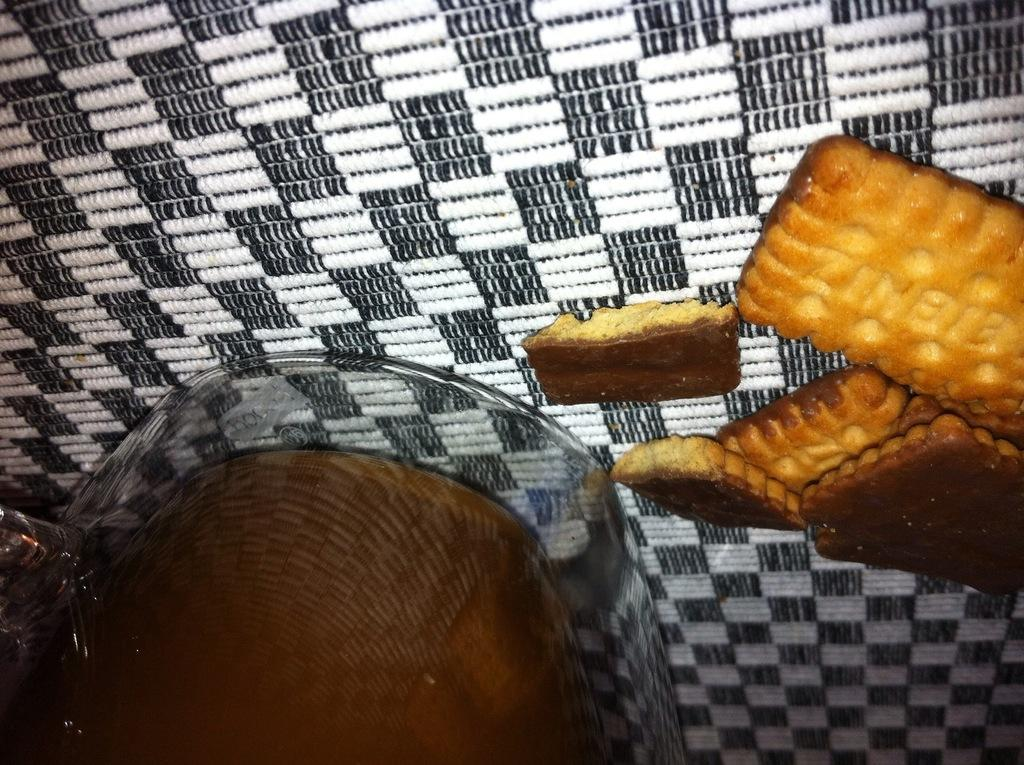What can be seen in the image? There is an object in the image. Can you describe the object on the platform in the image? There are biscuits on a platform in the image. How many people are in the crowd surrounding the object in the image? There is no crowd present in the image; it only shows an object and biscuits on a platform. What type of arithmetic problem can be solved using the object in the image? The object in the image does not involve any arithmetic problems. 